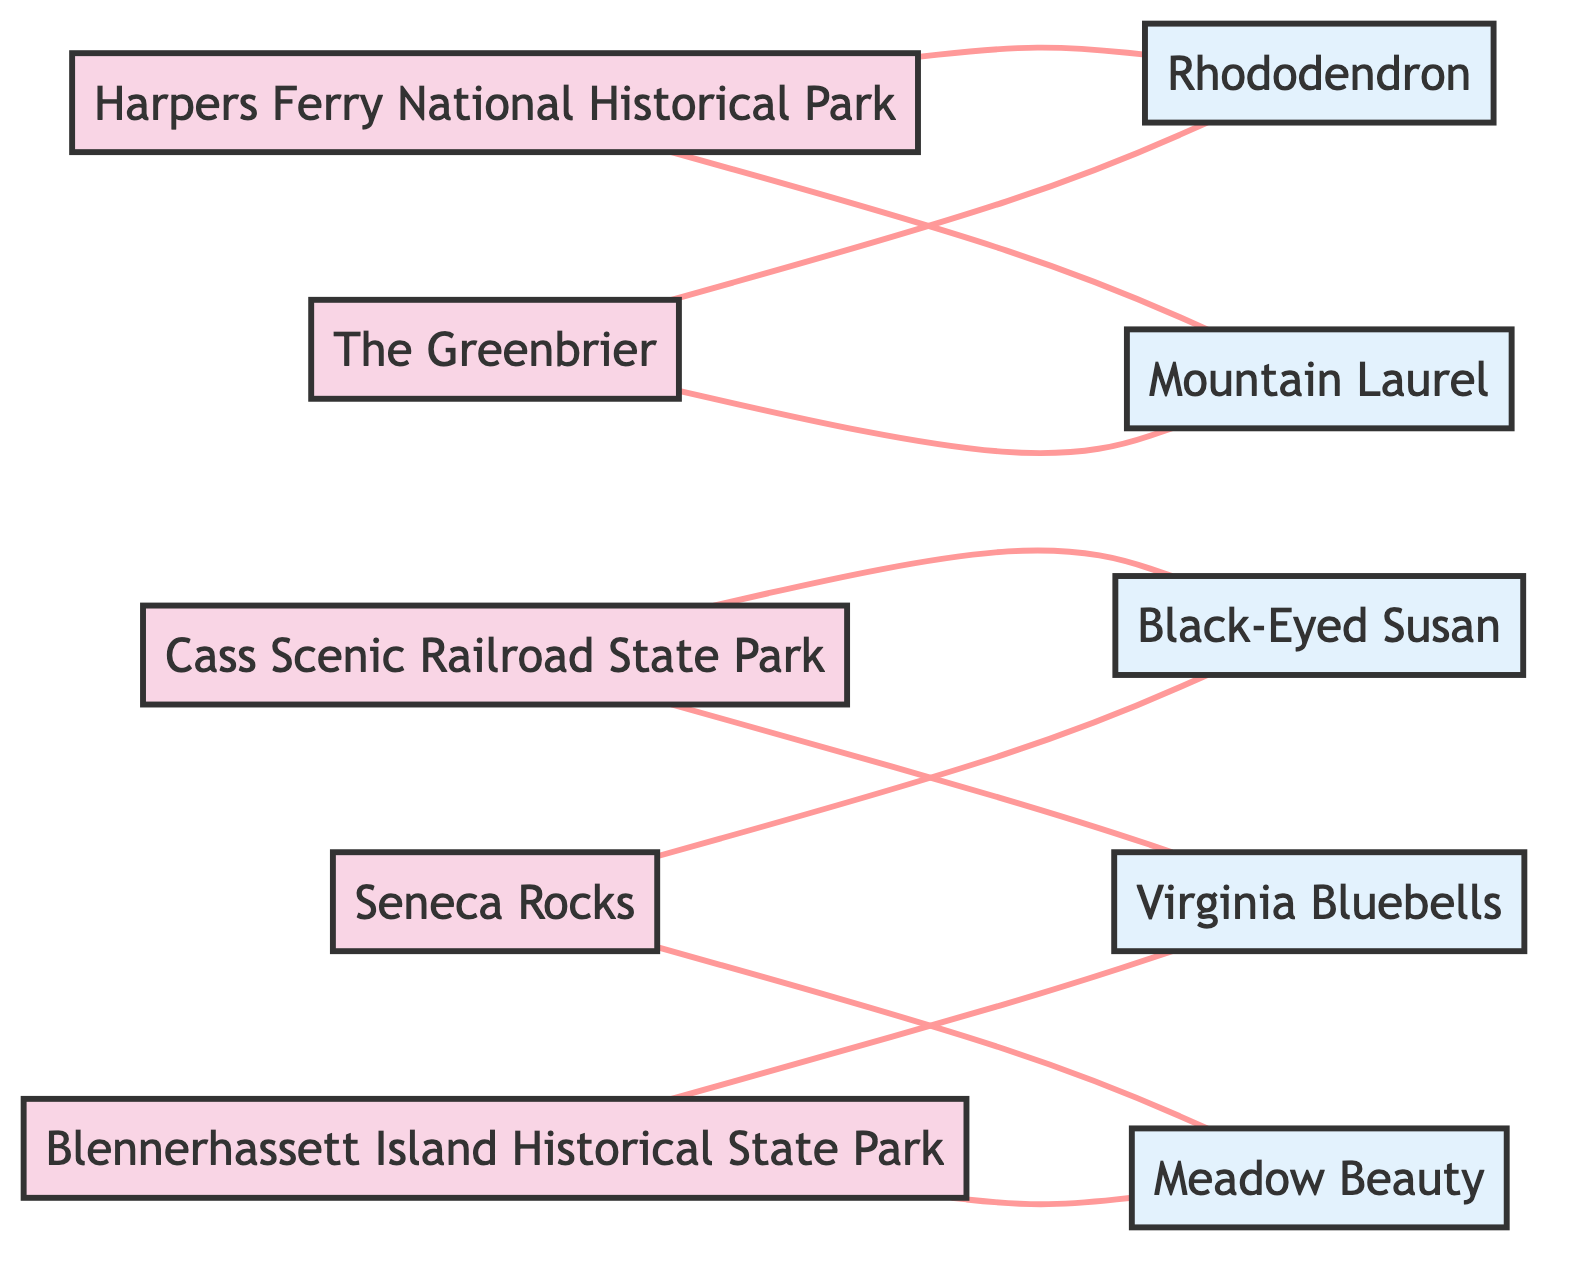What is the number of historical landmarks in the diagram? The diagram lists five distinct historical landmarks: Harpers Ferry National Historical Park, Cass Scenic Railroad State Park, The Greenbrier, Seneca Rocks, and Blennerhassett Island Historical State Park. By counting these nodes, we find there are five.
Answer: 5 Which flower is connected to Harpers Ferry National Historical Park? In the diagram, Harpers Ferry National Historical Park is directly connected to both Rhododendron and Mountain Laurel. Thus, these are the flowers associated with this landmark.
Answer: Rhododendron, Mountain Laurel How many edges connect to Cass Scenic Railroad State Park? Examining the diagram, Cass Scenic Railroad State Park is connected to two flowers: Black-Eyed Susan and Virginia Bluebells. This means there are two edges connected to this landmark.
Answer: 2 Is there any overlap in the flowers associated with The Greenbrier and Harpers Ferry National Historical Park? The Greenbrier is connected to Rhododendron and Mountain Laurel, while Harpers Ferry National Historical Park is also connected to Rhododendron and Mountain Laurel. Therefore, there is an overlap of these two flowers between the two landmarks.
Answer: Yes Which flower is linked to both Seneca Rocks and Blennerhassett Island Historical State Park? From the information available, Meadow Beauty is connected to Seneca Rocks and also linked to Blennerhassett Island Historical State Park. This indicates a common connection point for both landmarks.
Answer: Meadow Beauty How many unique flowers are represented in the diagram? The diagram lists the following unique flowers: Meadow Beauty, Rhododendron, Mountain Laurel, Black-Eyed Susan, and Virginia Bluebells. Counting these, we find there are five unique flower species represented overall.
Answer: 5 Which landmark has the most connections to flowers? By analyzing the connections, both Harpers Ferry National Historical Park and The Greenbrier are connected to two different flowers each, Rhododendron and Mountain Laurel. This indicates that multiple landmarks share the same number of connections, leading to a tie.
Answer: Harpers Ferry National Historical Park, The Greenbrier What is the relationship between Seneca Rocks and Black-Eyed Susan? In the diagram, there is a direct edge connecting Seneca Rocks to Black-Eyed Susan, indicating that Black-Eyed Susan is associated with this historical landmark.
Answer: Connected 